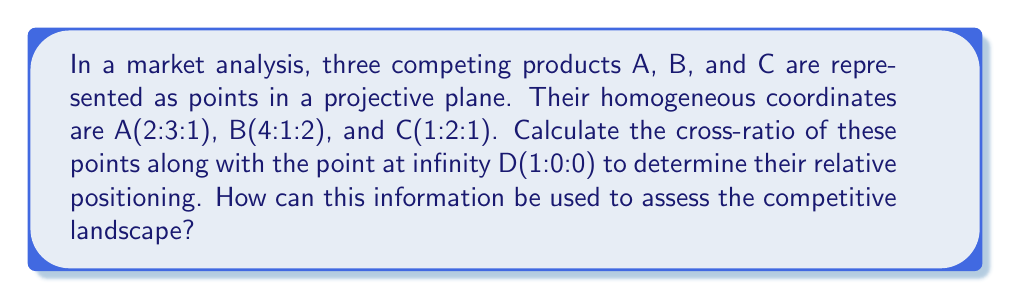Teach me how to tackle this problem. To solve this problem, we'll follow these steps:

1) The cross-ratio of four collinear points P, Q, R, S is defined as:

   $$(P,Q;R,S) = \frac{(P-R)(Q-S)}{(P-S)(Q-R)}$$

2) In projective geometry, we can use determinants to calculate the cross-ratio:

   $$(A,B;C,D) = \frac{|ACD||BBD|}{|ABD||BCD|}$$

   where |ACD| represents the determinant of the matrix formed by the coordinates of points A, C, and D.

3) Let's calculate each determinant:

   $$|ACD| = \begin{vmatrix}
   2 & 1 & 1 \\
   3 & 2 & 0 \\
   1 & 1 & 0
   \end{vmatrix} = 2(0) - 1(0) + 1(3-2) = 1$$

   $$|BBD| = \begin{vmatrix}
   4 & 4 & 1 \\
   1 & 1 & 0 \\
   2 & 2 & 0
   \end{vmatrix} = 4(0) - 4(0) + 1(2-2) = 0$$

   $$|ABD| = \begin{vmatrix}
   2 & 4 & 1 \\
   3 & 1 & 0 \\
   1 & 2 & 0
   \end{vmatrix} = 2(0) - 4(0) + 1(6-3) = 3$$

   $$|BCD| = \begin{vmatrix}
   4 & 1 & 1 \\
   1 & 2 & 0 \\
   2 & 1 & 0
   \end{vmatrix} = 4(0) - 1(0) + 1(2-1) = 1$$

4) Now we can calculate the cross-ratio:

   $$(A,B;C,D) = \frac{|ACD||BBD|}{|ABD||BCD|} = \frac{1 \cdot 0}{3 \cdot 1} = 0$$

5) Interpretation for market analysis:
   - A cross-ratio of 0 indicates that point B coincides with point D (the point at infinity).
   - This suggests that product B is positioned very differently from products A and C.
   - A and C are more closely related in terms of market positioning.
   - B might represent a niche or highly differentiated product in the market.

This information can be used to assess the competitive landscape by understanding the relative positioning of products. It helps identify which products are similar and which are differentiated, guiding strategic decisions on product development, marketing, and competitive strategy.
Answer: Cross-ratio $(A,B;C,D) = 0$, indicating B is distinctly positioned while A and C are more closely related. 